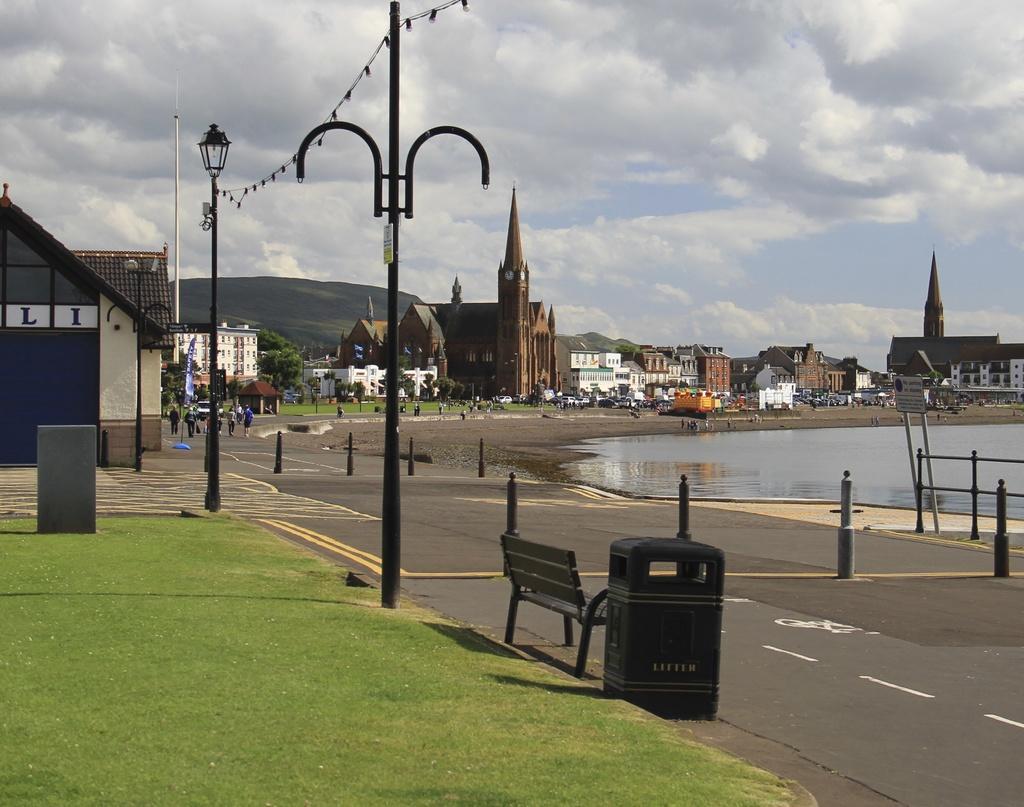Please provide a concise description of this image. This is the picture of a city. In this image there are buildings and trees and poles, vehicles and there are group of people walking on the road. In the foreground there there is a bench and dustbin. On the right side of the image there is water. At the top there is sky and there is water. At the bottom there is grass. 